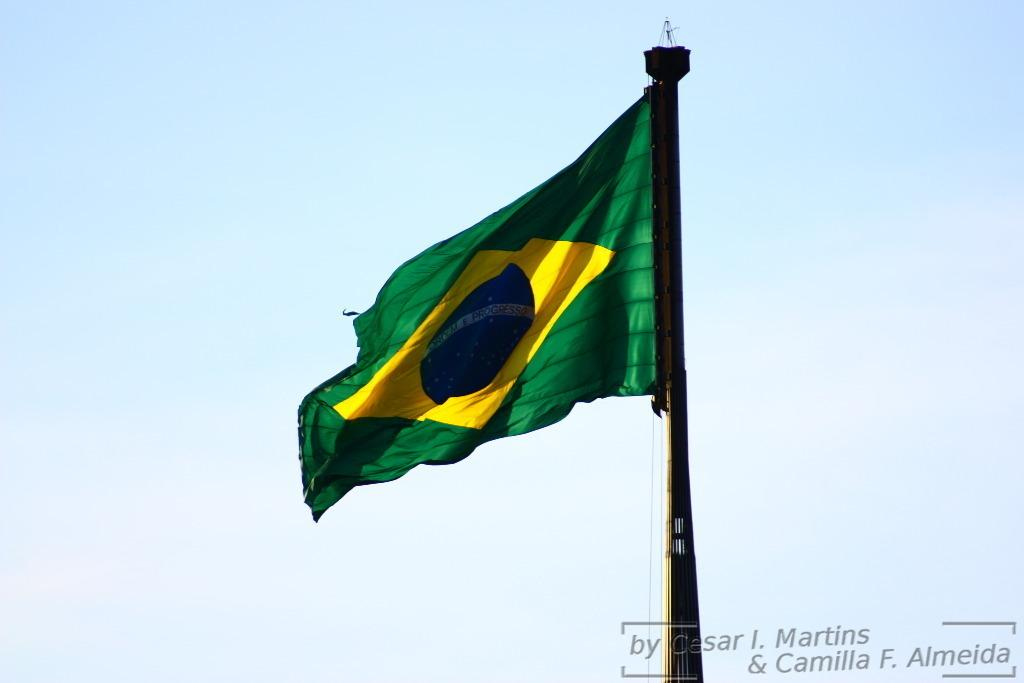What color is the flag in the image? The flag in the image is green. What can be seen in the background of the image? The sky is visible in the background of the image. What type of sticks are being used for breakfast in the image? There are no sticks or breakfast present in the image; it only features a green flag and the sky in the background. 